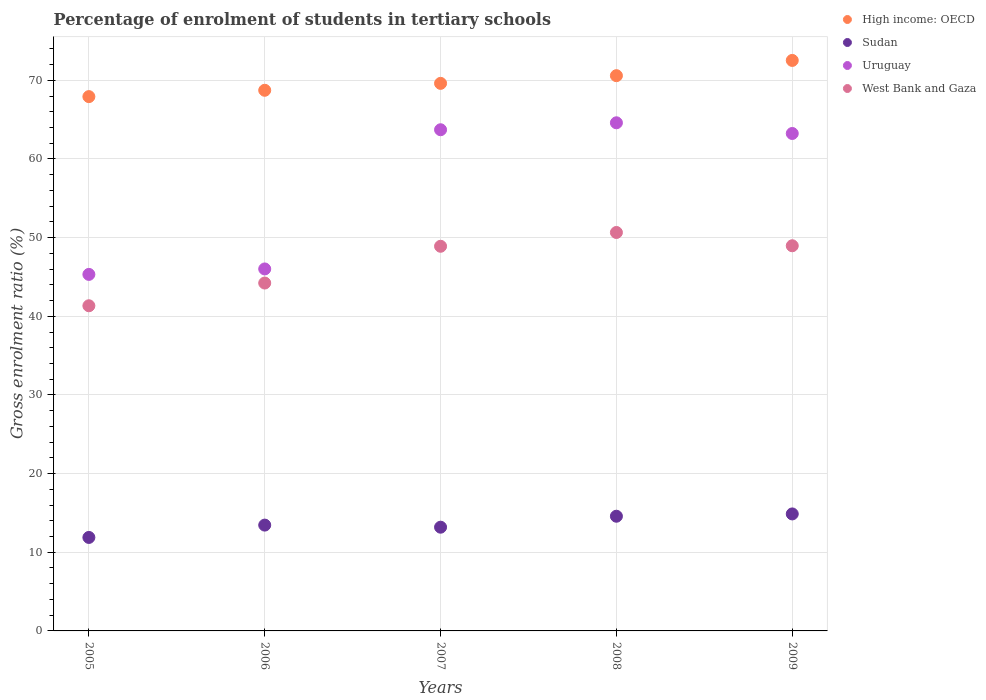How many different coloured dotlines are there?
Give a very brief answer. 4. What is the percentage of students enrolled in tertiary schools in West Bank and Gaza in 2006?
Offer a terse response. 44.23. Across all years, what is the maximum percentage of students enrolled in tertiary schools in Sudan?
Offer a terse response. 14.87. Across all years, what is the minimum percentage of students enrolled in tertiary schools in Sudan?
Make the answer very short. 11.88. What is the total percentage of students enrolled in tertiary schools in Uruguay in the graph?
Provide a succinct answer. 282.89. What is the difference between the percentage of students enrolled in tertiary schools in Uruguay in 2006 and that in 2007?
Give a very brief answer. -17.7. What is the difference between the percentage of students enrolled in tertiary schools in West Bank and Gaza in 2009 and the percentage of students enrolled in tertiary schools in Uruguay in 2008?
Make the answer very short. -15.63. What is the average percentage of students enrolled in tertiary schools in Sudan per year?
Your answer should be compact. 13.6. In the year 2008, what is the difference between the percentage of students enrolled in tertiary schools in High income: OECD and percentage of students enrolled in tertiary schools in West Bank and Gaza?
Offer a very short reply. 19.93. What is the ratio of the percentage of students enrolled in tertiary schools in West Bank and Gaza in 2006 to that in 2008?
Ensure brevity in your answer.  0.87. Is the percentage of students enrolled in tertiary schools in Uruguay in 2005 less than that in 2006?
Make the answer very short. Yes. What is the difference between the highest and the second highest percentage of students enrolled in tertiary schools in Sudan?
Ensure brevity in your answer.  0.29. What is the difference between the highest and the lowest percentage of students enrolled in tertiary schools in West Bank and Gaza?
Provide a short and direct response. 9.32. Is the sum of the percentage of students enrolled in tertiary schools in High income: OECD in 2006 and 2009 greater than the maximum percentage of students enrolled in tertiary schools in Sudan across all years?
Offer a very short reply. Yes. Is it the case that in every year, the sum of the percentage of students enrolled in tertiary schools in Uruguay and percentage of students enrolled in tertiary schools in High income: OECD  is greater than the sum of percentage of students enrolled in tertiary schools in West Bank and Gaza and percentage of students enrolled in tertiary schools in Sudan?
Keep it short and to the point. Yes. Does the percentage of students enrolled in tertiary schools in High income: OECD monotonically increase over the years?
Offer a very short reply. Yes. Is the percentage of students enrolled in tertiary schools in High income: OECD strictly less than the percentage of students enrolled in tertiary schools in West Bank and Gaza over the years?
Your answer should be compact. No. How many years are there in the graph?
Provide a succinct answer. 5. What is the difference between two consecutive major ticks on the Y-axis?
Keep it short and to the point. 10. How are the legend labels stacked?
Keep it short and to the point. Vertical. What is the title of the graph?
Make the answer very short. Percentage of enrolment of students in tertiary schools. What is the label or title of the Y-axis?
Make the answer very short. Gross enrolment ratio (%). What is the Gross enrolment ratio (%) of High income: OECD in 2005?
Provide a short and direct response. 67.93. What is the Gross enrolment ratio (%) in Sudan in 2005?
Your answer should be very brief. 11.88. What is the Gross enrolment ratio (%) of Uruguay in 2005?
Give a very brief answer. 45.32. What is the Gross enrolment ratio (%) in West Bank and Gaza in 2005?
Offer a terse response. 41.34. What is the Gross enrolment ratio (%) of High income: OECD in 2006?
Your answer should be very brief. 68.73. What is the Gross enrolment ratio (%) of Sudan in 2006?
Make the answer very short. 13.45. What is the Gross enrolment ratio (%) in Uruguay in 2006?
Provide a succinct answer. 46.02. What is the Gross enrolment ratio (%) of West Bank and Gaza in 2006?
Ensure brevity in your answer.  44.23. What is the Gross enrolment ratio (%) in High income: OECD in 2007?
Provide a short and direct response. 69.61. What is the Gross enrolment ratio (%) of Sudan in 2007?
Keep it short and to the point. 13.19. What is the Gross enrolment ratio (%) of Uruguay in 2007?
Give a very brief answer. 63.71. What is the Gross enrolment ratio (%) of West Bank and Gaza in 2007?
Offer a very short reply. 48.9. What is the Gross enrolment ratio (%) of High income: OECD in 2008?
Provide a succinct answer. 70.59. What is the Gross enrolment ratio (%) of Sudan in 2008?
Your response must be concise. 14.58. What is the Gross enrolment ratio (%) of Uruguay in 2008?
Your response must be concise. 64.6. What is the Gross enrolment ratio (%) in West Bank and Gaza in 2008?
Your response must be concise. 50.65. What is the Gross enrolment ratio (%) of High income: OECD in 2009?
Provide a succinct answer. 72.53. What is the Gross enrolment ratio (%) of Sudan in 2009?
Provide a succinct answer. 14.87. What is the Gross enrolment ratio (%) of Uruguay in 2009?
Your response must be concise. 63.24. What is the Gross enrolment ratio (%) of West Bank and Gaza in 2009?
Make the answer very short. 48.97. Across all years, what is the maximum Gross enrolment ratio (%) of High income: OECD?
Offer a terse response. 72.53. Across all years, what is the maximum Gross enrolment ratio (%) of Sudan?
Your answer should be compact. 14.87. Across all years, what is the maximum Gross enrolment ratio (%) in Uruguay?
Provide a succinct answer. 64.6. Across all years, what is the maximum Gross enrolment ratio (%) in West Bank and Gaza?
Provide a short and direct response. 50.65. Across all years, what is the minimum Gross enrolment ratio (%) of High income: OECD?
Your answer should be compact. 67.93. Across all years, what is the minimum Gross enrolment ratio (%) in Sudan?
Your answer should be very brief. 11.88. Across all years, what is the minimum Gross enrolment ratio (%) in Uruguay?
Your response must be concise. 45.32. Across all years, what is the minimum Gross enrolment ratio (%) in West Bank and Gaza?
Provide a short and direct response. 41.34. What is the total Gross enrolment ratio (%) in High income: OECD in the graph?
Your answer should be compact. 349.39. What is the total Gross enrolment ratio (%) of Sudan in the graph?
Provide a succinct answer. 67.98. What is the total Gross enrolment ratio (%) in Uruguay in the graph?
Your answer should be compact. 282.89. What is the total Gross enrolment ratio (%) of West Bank and Gaza in the graph?
Your answer should be compact. 234.09. What is the difference between the Gross enrolment ratio (%) of High income: OECD in 2005 and that in 2006?
Make the answer very short. -0.81. What is the difference between the Gross enrolment ratio (%) in Sudan in 2005 and that in 2006?
Your answer should be very brief. -1.57. What is the difference between the Gross enrolment ratio (%) in Uruguay in 2005 and that in 2006?
Your response must be concise. -0.69. What is the difference between the Gross enrolment ratio (%) of West Bank and Gaza in 2005 and that in 2006?
Your answer should be compact. -2.89. What is the difference between the Gross enrolment ratio (%) in High income: OECD in 2005 and that in 2007?
Your answer should be compact. -1.69. What is the difference between the Gross enrolment ratio (%) in Sudan in 2005 and that in 2007?
Your response must be concise. -1.3. What is the difference between the Gross enrolment ratio (%) in Uruguay in 2005 and that in 2007?
Keep it short and to the point. -18.39. What is the difference between the Gross enrolment ratio (%) of West Bank and Gaza in 2005 and that in 2007?
Offer a very short reply. -7.56. What is the difference between the Gross enrolment ratio (%) of High income: OECD in 2005 and that in 2008?
Ensure brevity in your answer.  -2.66. What is the difference between the Gross enrolment ratio (%) in Sudan in 2005 and that in 2008?
Make the answer very short. -2.7. What is the difference between the Gross enrolment ratio (%) of Uruguay in 2005 and that in 2008?
Provide a short and direct response. -19.27. What is the difference between the Gross enrolment ratio (%) of West Bank and Gaza in 2005 and that in 2008?
Keep it short and to the point. -9.32. What is the difference between the Gross enrolment ratio (%) of High income: OECD in 2005 and that in 2009?
Your answer should be very brief. -4.6. What is the difference between the Gross enrolment ratio (%) of Sudan in 2005 and that in 2009?
Make the answer very short. -2.99. What is the difference between the Gross enrolment ratio (%) of Uruguay in 2005 and that in 2009?
Provide a succinct answer. -17.91. What is the difference between the Gross enrolment ratio (%) in West Bank and Gaza in 2005 and that in 2009?
Your answer should be compact. -7.63. What is the difference between the Gross enrolment ratio (%) of High income: OECD in 2006 and that in 2007?
Make the answer very short. -0.88. What is the difference between the Gross enrolment ratio (%) of Sudan in 2006 and that in 2007?
Offer a terse response. 0.27. What is the difference between the Gross enrolment ratio (%) of Uruguay in 2006 and that in 2007?
Keep it short and to the point. -17.7. What is the difference between the Gross enrolment ratio (%) of West Bank and Gaza in 2006 and that in 2007?
Your answer should be compact. -4.67. What is the difference between the Gross enrolment ratio (%) of High income: OECD in 2006 and that in 2008?
Keep it short and to the point. -1.86. What is the difference between the Gross enrolment ratio (%) of Sudan in 2006 and that in 2008?
Your answer should be very brief. -1.13. What is the difference between the Gross enrolment ratio (%) of Uruguay in 2006 and that in 2008?
Keep it short and to the point. -18.58. What is the difference between the Gross enrolment ratio (%) of West Bank and Gaza in 2006 and that in 2008?
Offer a very short reply. -6.43. What is the difference between the Gross enrolment ratio (%) in High income: OECD in 2006 and that in 2009?
Provide a succinct answer. -3.8. What is the difference between the Gross enrolment ratio (%) of Sudan in 2006 and that in 2009?
Ensure brevity in your answer.  -1.42. What is the difference between the Gross enrolment ratio (%) of Uruguay in 2006 and that in 2009?
Your answer should be compact. -17.22. What is the difference between the Gross enrolment ratio (%) in West Bank and Gaza in 2006 and that in 2009?
Ensure brevity in your answer.  -4.74. What is the difference between the Gross enrolment ratio (%) of High income: OECD in 2007 and that in 2008?
Make the answer very short. -0.98. What is the difference between the Gross enrolment ratio (%) of Sudan in 2007 and that in 2008?
Ensure brevity in your answer.  -1.39. What is the difference between the Gross enrolment ratio (%) in Uruguay in 2007 and that in 2008?
Your answer should be very brief. -0.88. What is the difference between the Gross enrolment ratio (%) of West Bank and Gaza in 2007 and that in 2008?
Provide a short and direct response. -1.75. What is the difference between the Gross enrolment ratio (%) of High income: OECD in 2007 and that in 2009?
Your answer should be compact. -2.92. What is the difference between the Gross enrolment ratio (%) in Sudan in 2007 and that in 2009?
Your response must be concise. -1.69. What is the difference between the Gross enrolment ratio (%) of Uruguay in 2007 and that in 2009?
Offer a terse response. 0.48. What is the difference between the Gross enrolment ratio (%) in West Bank and Gaza in 2007 and that in 2009?
Offer a terse response. -0.06. What is the difference between the Gross enrolment ratio (%) of High income: OECD in 2008 and that in 2009?
Your answer should be very brief. -1.94. What is the difference between the Gross enrolment ratio (%) of Sudan in 2008 and that in 2009?
Offer a terse response. -0.29. What is the difference between the Gross enrolment ratio (%) in Uruguay in 2008 and that in 2009?
Your response must be concise. 1.36. What is the difference between the Gross enrolment ratio (%) in West Bank and Gaza in 2008 and that in 2009?
Make the answer very short. 1.69. What is the difference between the Gross enrolment ratio (%) of High income: OECD in 2005 and the Gross enrolment ratio (%) of Sudan in 2006?
Provide a succinct answer. 54.47. What is the difference between the Gross enrolment ratio (%) of High income: OECD in 2005 and the Gross enrolment ratio (%) of Uruguay in 2006?
Your answer should be very brief. 21.91. What is the difference between the Gross enrolment ratio (%) in High income: OECD in 2005 and the Gross enrolment ratio (%) in West Bank and Gaza in 2006?
Your answer should be compact. 23.7. What is the difference between the Gross enrolment ratio (%) of Sudan in 2005 and the Gross enrolment ratio (%) of Uruguay in 2006?
Ensure brevity in your answer.  -34.13. What is the difference between the Gross enrolment ratio (%) in Sudan in 2005 and the Gross enrolment ratio (%) in West Bank and Gaza in 2006?
Your answer should be compact. -32.34. What is the difference between the Gross enrolment ratio (%) of Uruguay in 2005 and the Gross enrolment ratio (%) of West Bank and Gaza in 2006?
Keep it short and to the point. 1.1. What is the difference between the Gross enrolment ratio (%) of High income: OECD in 2005 and the Gross enrolment ratio (%) of Sudan in 2007?
Your answer should be very brief. 54.74. What is the difference between the Gross enrolment ratio (%) in High income: OECD in 2005 and the Gross enrolment ratio (%) in Uruguay in 2007?
Your answer should be compact. 4.21. What is the difference between the Gross enrolment ratio (%) of High income: OECD in 2005 and the Gross enrolment ratio (%) of West Bank and Gaza in 2007?
Your answer should be compact. 19.03. What is the difference between the Gross enrolment ratio (%) in Sudan in 2005 and the Gross enrolment ratio (%) in Uruguay in 2007?
Provide a succinct answer. -51.83. What is the difference between the Gross enrolment ratio (%) in Sudan in 2005 and the Gross enrolment ratio (%) in West Bank and Gaza in 2007?
Your response must be concise. -37.02. What is the difference between the Gross enrolment ratio (%) of Uruguay in 2005 and the Gross enrolment ratio (%) of West Bank and Gaza in 2007?
Provide a succinct answer. -3.58. What is the difference between the Gross enrolment ratio (%) of High income: OECD in 2005 and the Gross enrolment ratio (%) of Sudan in 2008?
Make the answer very short. 53.35. What is the difference between the Gross enrolment ratio (%) of High income: OECD in 2005 and the Gross enrolment ratio (%) of Uruguay in 2008?
Make the answer very short. 3.33. What is the difference between the Gross enrolment ratio (%) of High income: OECD in 2005 and the Gross enrolment ratio (%) of West Bank and Gaza in 2008?
Offer a terse response. 17.27. What is the difference between the Gross enrolment ratio (%) in Sudan in 2005 and the Gross enrolment ratio (%) in Uruguay in 2008?
Your answer should be very brief. -52.71. What is the difference between the Gross enrolment ratio (%) of Sudan in 2005 and the Gross enrolment ratio (%) of West Bank and Gaza in 2008?
Give a very brief answer. -38.77. What is the difference between the Gross enrolment ratio (%) in Uruguay in 2005 and the Gross enrolment ratio (%) in West Bank and Gaza in 2008?
Offer a terse response. -5.33. What is the difference between the Gross enrolment ratio (%) of High income: OECD in 2005 and the Gross enrolment ratio (%) of Sudan in 2009?
Provide a succinct answer. 53.05. What is the difference between the Gross enrolment ratio (%) of High income: OECD in 2005 and the Gross enrolment ratio (%) of Uruguay in 2009?
Keep it short and to the point. 4.69. What is the difference between the Gross enrolment ratio (%) of High income: OECD in 2005 and the Gross enrolment ratio (%) of West Bank and Gaza in 2009?
Ensure brevity in your answer.  18.96. What is the difference between the Gross enrolment ratio (%) in Sudan in 2005 and the Gross enrolment ratio (%) in Uruguay in 2009?
Provide a succinct answer. -51.36. What is the difference between the Gross enrolment ratio (%) in Sudan in 2005 and the Gross enrolment ratio (%) in West Bank and Gaza in 2009?
Ensure brevity in your answer.  -37.08. What is the difference between the Gross enrolment ratio (%) of Uruguay in 2005 and the Gross enrolment ratio (%) of West Bank and Gaza in 2009?
Give a very brief answer. -3.64. What is the difference between the Gross enrolment ratio (%) in High income: OECD in 2006 and the Gross enrolment ratio (%) in Sudan in 2007?
Keep it short and to the point. 55.54. What is the difference between the Gross enrolment ratio (%) in High income: OECD in 2006 and the Gross enrolment ratio (%) in Uruguay in 2007?
Give a very brief answer. 5.02. What is the difference between the Gross enrolment ratio (%) in High income: OECD in 2006 and the Gross enrolment ratio (%) in West Bank and Gaza in 2007?
Provide a short and direct response. 19.83. What is the difference between the Gross enrolment ratio (%) of Sudan in 2006 and the Gross enrolment ratio (%) of Uruguay in 2007?
Provide a succinct answer. -50.26. What is the difference between the Gross enrolment ratio (%) in Sudan in 2006 and the Gross enrolment ratio (%) in West Bank and Gaza in 2007?
Keep it short and to the point. -35.45. What is the difference between the Gross enrolment ratio (%) in Uruguay in 2006 and the Gross enrolment ratio (%) in West Bank and Gaza in 2007?
Ensure brevity in your answer.  -2.88. What is the difference between the Gross enrolment ratio (%) of High income: OECD in 2006 and the Gross enrolment ratio (%) of Sudan in 2008?
Make the answer very short. 54.15. What is the difference between the Gross enrolment ratio (%) in High income: OECD in 2006 and the Gross enrolment ratio (%) in Uruguay in 2008?
Make the answer very short. 4.13. What is the difference between the Gross enrolment ratio (%) of High income: OECD in 2006 and the Gross enrolment ratio (%) of West Bank and Gaza in 2008?
Ensure brevity in your answer.  18.08. What is the difference between the Gross enrolment ratio (%) in Sudan in 2006 and the Gross enrolment ratio (%) in Uruguay in 2008?
Ensure brevity in your answer.  -51.15. What is the difference between the Gross enrolment ratio (%) of Sudan in 2006 and the Gross enrolment ratio (%) of West Bank and Gaza in 2008?
Your response must be concise. -37.2. What is the difference between the Gross enrolment ratio (%) in Uruguay in 2006 and the Gross enrolment ratio (%) in West Bank and Gaza in 2008?
Give a very brief answer. -4.64. What is the difference between the Gross enrolment ratio (%) in High income: OECD in 2006 and the Gross enrolment ratio (%) in Sudan in 2009?
Your answer should be compact. 53.86. What is the difference between the Gross enrolment ratio (%) in High income: OECD in 2006 and the Gross enrolment ratio (%) in Uruguay in 2009?
Provide a short and direct response. 5.49. What is the difference between the Gross enrolment ratio (%) in High income: OECD in 2006 and the Gross enrolment ratio (%) in West Bank and Gaza in 2009?
Provide a short and direct response. 19.77. What is the difference between the Gross enrolment ratio (%) in Sudan in 2006 and the Gross enrolment ratio (%) in Uruguay in 2009?
Make the answer very short. -49.79. What is the difference between the Gross enrolment ratio (%) of Sudan in 2006 and the Gross enrolment ratio (%) of West Bank and Gaza in 2009?
Your answer should be very brief. -35.51. What is the difference between the Gross enrolment ratio (%) of Uruguay in 2006 and the Gross enrolment ratio (%) of West Bank and Gaza in 2009?
Your response must be concise. -2.95. What is the difference between the Gross enrolment ratio (%) in High income: OECD in 2007 and the Gross enrolment ratio (%) in Sudan in 2008?
Provide a short and direct response. 55.03. What is the difference between the Gross enrolment ratio (%) of High income: OECD in 2007 and the Gross enrolment ratio (%) of Uruguay in 2008?
Make the answer very short. 5.01. What is the difference between the Gross enrolment ratio (%) in High income: OECD in 2007 and the Gross enrolment ratio (%) in West Bank and Gaza in 2008?
Your answer should be compact. 18.96. What is the difference between the Gross enrolment ratio (%) in Sudan in 2007 and the Gross enrolment ratio (%) in Uruguay in 2008?
Make the answer very short. -51.41. What is the difference between the Gross enrolment ratio (%) of Sudan in 2007 and the Gross enrolment ratio (%) of West Bank and Gaza in 2008?
Offer a terse response. -37.47. What is the difference between the Gross enrolment ratio (%) in Uruguay in 2007 and the Gross enrolment ratio (%) in West Bank and Gaza in 2008?
Your answer should be very brief. 13.06. What is the difference between the Gross enrolment ratio (%) in High income: OECD in 2007 and the Gross enrolment ratio (%) in Sudan in 2009?
Offer a terse response. 54.74. What is the difference between the Gross enrolment ratio (%) of High income: OECD in 2007 and the Gross enrolment ratio (%) of Uruguay in 2009?
Give a very brief answer. 6.37. What is the difference between the Gross enrolment ratio (%) in High income: OECD in 2007 and the Gross enrolment ratio (%) in West Bank and Gaza in 2009?
Give a very brief answer. 20.65. What is the difference between the Gross enrolment ratio (%) of Sudan in 2007 and the Gross enrolment ratio (%) of Uruguay in 2009?
Offer a terse response. -50.05. What is the difference between the Gross enrolment ratio (%) in Sudan in 2007 and the Gross enrolment ratio (%) in West Bank and Gaza in 2009?
Give a very brief answer. -35.78. What is the difference between the Gross enrolment ratio (%) in Uruguay in 2007 and the Gross enrolment ratio (%) in West Bank and Gaza in 2009?
Your response must be concise. 14.75. What is the difference between the Gross enrolment ratio (%) of High income: OECD in 2008 and the Gross enrolment ratio (%) of Sudan in 2009?
Provide a short and direct response. 55.72. What is the difference between the Gross enrolment ratio (%) of High income: OECD in 2008 and the Gross enrolment ratio (%) of Uruguay in 2009?
Offer a terse response. 7.35. What is the difference between the Gross enrolment ratio (%) of High income: OECD in 2008 and the Gross enrolment ratio (%) of West Bank and Gaza in 2009?
Provide a short and direct response. 21.62. What is the difference between the Gross enrolment ratio (%) in Sudan in 2008 and the Gross enrolment ratio (%) in Uruguay in 2009?
Offer a terse response. -48.66. What is the difference between the Gross enrolment ratio (%) of Sudan in 2008 and the Gross enrolment ratio (%) of West Bank and Gaza in 2009?
Offer a very short reply. -34.39. What is the difference between the Gross enrolment ratio (%) in Uruguay in 2008 and the Gross enrolment ratio (%) in West Bank and Gaza in 2009?
Keep it short and to the point. 15.63. What is the average Gross enrolment ratio (%) in High income: OECD per year?
Keep it short and to the point. 69.88. What is the average Gross enrolment ratio (%) in Sudan per year?
Ensure brevity in your answer.  13.6. What is the average Gross enrolment ratio (%) in Uruguay per year?
Your answer should be compact. 56.58. What is the average Gross enrolment ratio (%) of West Bank and Gaza per year?
Your answer should be compact. 46.82. In the year 2005, what is the difference between the Gross enrolment ratio (%) in High income: OECD and Gross enrolment ratio (%) in Sudan?
Your answer should be very brief. 56.04. In the year 2005, what is the difference between the Gross enrolment ratio (%) in High income: OECD and Gross enrolment ratio (%) in Uruguay?
Provide a short and direct response. 22.6. In the year 2005, what is the difference between the Gross enrolment ratio (%) of High income: OECD and Gross enrolment ratio (%) of West Bank and Gaza?
Ensure brevity in your answer.  26.59. In the year 2005, what is the difference between the Gross enrolment ratio (%) of Sudan and Gross enrolment ratio (%) of Uruguay?
Provide a succinct answer. -33.44. In the year 2005, what is the difference between the Gross enrolment ratio (%) of Sudan and Gross enrolment ratio (%) of West Bank and Gaza?
Your answer should be compact. -29.45. In the year 2005, what is the difference between the Gross enrolment ratio (%) of Uruguay and Gross enrolment ratio (%) of West Bank and Gaza?
Your response must be concise. 3.99. In the year 2006, what is the difference between the Gross enrolment ratio (%) of High income: OECD and Gross enrolment ratio (%) of Sudan?
Give a very brief answer. 55.28. In the year 2006, what is the difference between the Gross enrolment ratio (%) in High income: OECD and Gross enrolment ratio (%) in Uruguay?
Your response must be concise. 22.71. In the year 2006, what is the difference between the Gross enrolment ratio (%) of High income: OECD and Gross enrolment ratio (%) of West Bank and Gaza?
Make the answer very short. 24.5. In the year 2006, what is the difference between the Gross enrolment ratio (%) in Sudan and Gross enrolment ratio (%) in Uruguay?
Keep it short and to the point. -32.56. In the year 2006, what is the difference between the Gross enrolment ratio (%) in Sudan and Gross enrolment ratio (%) in West Bank and Gaza?
Give a very brief answer. -30.77. In the year 2006, what is the difference between the Gross enrolment ratio (%) in Uruguay and Gross enrolment ratio (%) in West Bank and Gaza?
Give a very brief answer. 1.79. In the year 2007, what is the difference between the Gross enrolment ratio (%) of High income: OECD and Gross enrolment ratio (%) of Sudan?
Provide a succinct answer. 56.42. In the year 2007, what is the difference between the Gross enrolment ratio (%) of High income: OECD and Gross enrolment ratio (%) of Uruguay?
Make the answer very short. 5.9. In the year 2007, what is the difference between the Gross enrolment ratio (%) in High income: OECD and Gross enrolment ratio (%) in West Bank and Gaza?
Your answer should be very brief. 20.71. In the year 2007, what is the difference between the Gross enrolment ratio (%) of Sudan and Gross enrolment ratio (%) of Uruguay?
Make the answer very short. -50.53. In the year 2007, what is the difference between the Gross enrolment ratio (%) in Sudan and Gross enrolment ratio (%) in West Bank and Gaza?
Keep it short and to the point. -35.71. In the year 2007, what is the difference between the Gross enrolment ratio (%) in Uruguay and Gross enrolment ratio (%) in West Bank and Gaza?
Your answer should be very brief. 14.81. In the year 2008, what is the difference between the Gross enrolment ratio (%) of High income: OECD and Gross enrolment ratio (%) of Sudan?
Give a very brief answer. 56.01. In the year 2008, what is the difference between the Gross enrolment ratio (%) of High income: OECD and Gross enrolment ratio (%) of Uruguay?
Offer a terse response. 5.99. In the year 2008, what is the difference between the Gross enrolment ratio (%) in High income: OECD and Gross enrolment ratio (%) in West Bank and Gaza?
Keep it short and to the point. 19.93. In the year 2008, what is the difference between the Gross enrolment ratio (%) of Sudan and Gross enrolment ratio (%) of Uruguay?
Your response must be concise. -50.02. In the year 2008, what is the difference between the Gross enrolment ratio (%) in Sudan and Gross enrolment ratio (%) in West Bank and Gaza?
Make the answer very short. -36.07. In the year 2008, what is the difference between the Gross enrolment ratio (%) of Uruguay and Gross enrolment ratio (%) of West Bank and Gaza?
Offer a very short reply. 13.94. In the year 2009, what is the difference between the Gross enrolment ratio (%) of High income: OECD and Gross enrolment ratio (%) of Sudan?
Provide a short and direct response. 57.65. In the year 2009, what is the difference between the Gross enrolment ratio (%) of High income: OECD and Gross enrolment ratio (%) of Uruguay?
Keep it short and to the point. 9.29. In the year 2009, what is the difference between the Gross enrolment ratio (%) of High income: OECD and Gross enrolment ratio (%) of West Bank and Gaza?
Offer a terse response. 23.56. In the year 2009, what is the difference between the Gross enrolment ratio (%) of Sudan and Gross enrolment ratio (%) of Uruguay?
Ensure brevity in your answer.  -48.37. In the year 2009, what is the difference between the Gross enrolment ratio (%) in Sudan and Gross enrolment ratio (%) in West Bank and Gaza?
Make the answer very short. -34.09. In the year 2009, what is the difference between the Gross enrolment ratio (%) in Uruguay and Gross enrolment ratio (%) in West Bank and Gaza?
Provide a succinct answer. 14.27. What is the ratio of the Gross enrolment ratio (%) in High income: OECD in 2005 to that in 2006?
Your response must be concise. 0.99. What is the ratio of the Gross enrolment ratio (%) of Sudan in 2005 to that in 2006?
Make the answer very short. 0.88. What is the ratio of the Gross enrolment ratio (%) of Uruguay in 2005 to that in 2006?
Ensure brevity in your answer.  0.98. What is the ratio of the Gross enrolment ratio (%) in West Bank and Gaza in 2005 to that in 2006?
Provide a succinct answer. 0.93. What is the ratio of the Gross enrolment ratio (%) in High income: OECD in 2005 to that in 2007?
Make the answer very short. 0.98. What is the ratio of the Gross enrolment ratio (%) of Sudan in 2005 to that in 2007?
Your answer should be very brief. 0.9. What is the ratio of the Gross enrolment ratio (%) of Uruguay in 2005 to that in 2007?
Ensure brevity in your answer.  0.71. What is the ratio of the Gross enrolment ratio (%) in West Bank and Gaza in 2005 to that in 2007?
Provide a short and direct response. 0.85. What is the ratio of the Gross enrolment ratio (%) of High income: OECD in 2005 to that in 2008?
Make the answer very short. 0.96. What is the ratio of the Gross enrolment ratio (%) of Sudan in 2005 to that in 2008?
Provide a short and direct response. 0.82. What is the ratio of the Gross enrolment ratio (%) of Uruguay in 2005 to that in 2008?
Give a very brief answer. 0.7. What is the ratio of the Gross enrolment ratio (%) in West Bank and Gaza in 2005 to that in 2008?
Make the answer very short. 0.82. What is the ratio of the Gross enrolment ratio (%) in High income: OECD in 2005 to that in 2009?
Your response must be concise. 0.94. What is the ratio of the Gross enrolment ratio (%) in Sudan in 2005 to that in 2009?
Offer a very short reply. 0.8. What is the ratio of the Gross enrolment ratio (%) of Uruguay in 2005 to that in 2009?
Provide a short and direct response. 0.72. What is the ratio of the Gross enrolment ratio (%) of West Bank and Gaza in 2005 to that in 2009?
Your answer should be very brief. 0.84. What is the ratio of the Gross enrolment ratio (%) in High income: OECD in 2006 to that in 2007?
Offer a very short reply. 0.99. What is the ratio of the Gross enrolment ratio (%) in Sudan in 2006 to that in 2007?
Your answer should be compact. 1.02. What is the ratio of the Gross enrolment ratio (%) in Uruguay in 2006 to that in 2007?
Your answer should be compact. 0.72. What is the ratio of the Gross enrolment ratio (%) in West Bank and Gaza in 2006 to that in 2007?
Give a very brief answer. 0.9. What is the ratio of the Gross enrolment ratio (%) in High income: OECD in 2006 to that in 2008?
Provide a short and direct response. 0.97. What is the ratio of the Gross enrolment ratio (%) of Sudan in 2006 to that in 2008?
Make the answer very short. 0.92. What is the ratio of the Gross enrolment ratio (%) in Uruguay in 2006 to that in 2008?
Your response must be concise. 0.71. What is the ratio of the Gross enrolment ratio (%) of West Bank and Gaza in 2006 to that in 2008?
Your answer should be very brief. 0.87. What is the ratio of the Gross enrolment ratio (%) in High income: OECD in 2006 to that in 2009?
Give a very brief answer. 0.95. What is the ratio of the Gross enrolment ratio (%) in Sudan in 2006 to that in 2009?
Give a very brief answer. 0.9. What is the ratio of the Gross enrolment ratio (%) in Uruguay in 2006 to that in 2009?
Provide a short and direct response. 0.73. What is the ratio of the Gross enrolment ratio (%) in West Bank and Gaza in 2006 to that in 2009?
Give a very brief answer. 0.9. What is the ratio of the Gross enrolment ratio (%) of High income: OECD in 2007 to that in 2008?
Provide a succinct answer. 0.99. What is the ratio of the Gross enrolment ratio (%) of Sudan in 2007 to that in 2008?
Provide a short and direct response. 0.9. What is the ratio of the Gross enrolment ratio (%) in Uruguay in 2007 to that in 2008?
Provide a short and direct response. 0.99. What is the ratio of the Gross enrolment ratio (%) in West Bank and Gaza in 2007 to that in 2008?
Make the answer very short. 0.97. What is the ratio of the Gross enrolment ratio (%) in High income: OECD in 2007 to that in 2009?
Ensure brevity in your answer.  0.96. What is the ratio of the Gross enrolment ratio (%) of Sudan in 2007 to that in 2009?
Offer a terse response. 0.89. What is the ratio of the Gross enrolment ratio (%) of Uruguay in 2007 to that in 2009?
Your answer should be very brief. 1.01. What is the ratio of the Gross enrolment ratio (%) of High income: OECD in 2008 to that in 2009?
Give a very brief answer. 0.97. What is the ratio of the Gross enrolment ratio (%) in Sudan in 2008 to that in 2009?
Ensure brevity in your answer.  0.98. What is the ratio of the Gross enrolment ratio (%) in Uruguay in 2008 to that in 2009?
Give a very brief answer. 1.02. What is the ratio of the Gross enrolment ratio (%) of West Bank and Gaza in 2008 to that in 2009?
Keep it short and to the point. 1.03. What is the difference between the highest and the second highest Gross enrolment ratio (%) of High income: OECD?
Your response must be concise. 1.94. What is the difference between the highest and the second highest Gross enrolment ratio (%) in Sudan?
Keep it short and to the point. 0.29. What is the difference between the highest and the second highest Gross enrolment ratio (%) in Uruguay?
Provide a succinct answer. 0.88. What is the difference between the highest and the second highest Gross enrolment ratio (%) of West Bank and Gaza?
Your answer should be compact. 1.69. What is the difference between the highest and the lowest Gross enrolment ratio (%) of High income: OECD?
Keep it short and to the point. 4.6. What is the difference between the highest and the lowest Gross enrolment ratio (%) in Sudan?
Ensure brevity in your answer.  2.99. What is the difference between the highest and the lowest Gross enrolment ratio (%) of Uruguay?
Give a very brief answer. 19.27. What is the difference between the highest and the lowest Gross enrolment ratio (%) of West Bank and Gaza?
Provide a succinct answer. 9.32. 